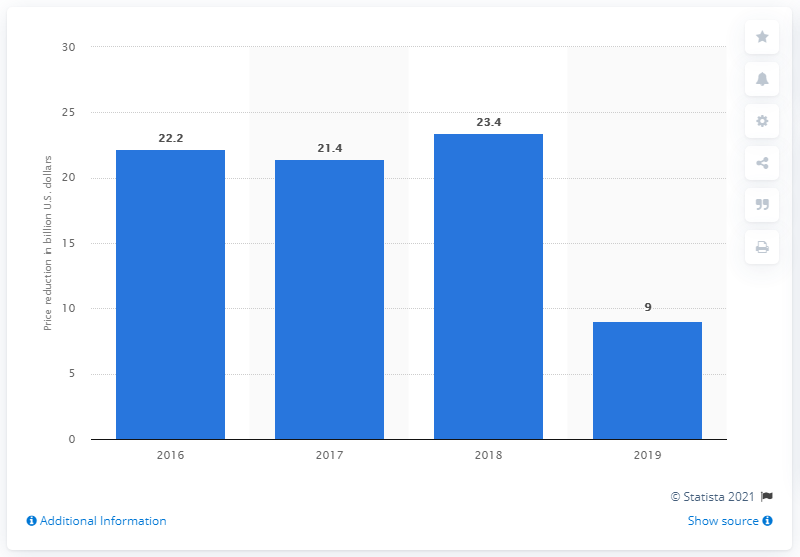Draw attention to some important aspects in this diagram. The price reduction for expiring patents in 2016 was 22.2%. 